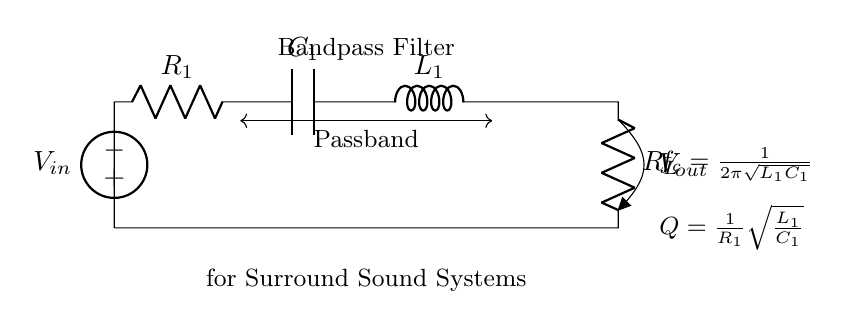What type of circuit is shown? The circuit is a bandpass filter, evidenced by its configuration of resistors, capacitors, and inductors which allows certain frequency ranges to pass through while attenuating others.
Answer: Bandpass filter What components are in the circuit? The circuit contains two resistors, one capacitor, and one inductor, which are characteristic components that form the topology of a bandpass filter.
Answer: Two resistors, one capacitor, one inductor What is the input voltage represented as? The input voltage is denoted as V_in, labeled at the voltage source connecting to the circuit, indicating where the signal enters the filter.
Answer: V_in What does V_out represent? The output voltage, labeled as V_out, represents the filtered signal that exits the circuit after passing through the components tuned to isolate specific frequencies.
Answer: V_out What is the formula for the cutoff frequency? The formula for the cutoff frequency is given as f_c = 1 over 2π times the square root of L_1 and C_1, which shows the mathematical relationship determining the frequency at which the filter begins to pass signals.
Answer: 1 over 2π times sqrt(L_1C_1) What does the Q factor indicate? The Q factor indicates the selectivity or sharpness of the filter's passband, and is defined by the formula Q = 1 over R_1 times the square root of L_1 over C_1. This value influences how well the filter can isolate a narrow frequency range.
Answer: 1 over R_1 times sqrt(L_1 over C_1) What is the relationship between L_1 and C_1 in determining frequency? The relationship shows that the values of L_1 and C_1 directly affect the resonant frequency f_c, meaning varying these components will change the frequencies that the filter passes through.
Answer: They determine cut-off frequency 